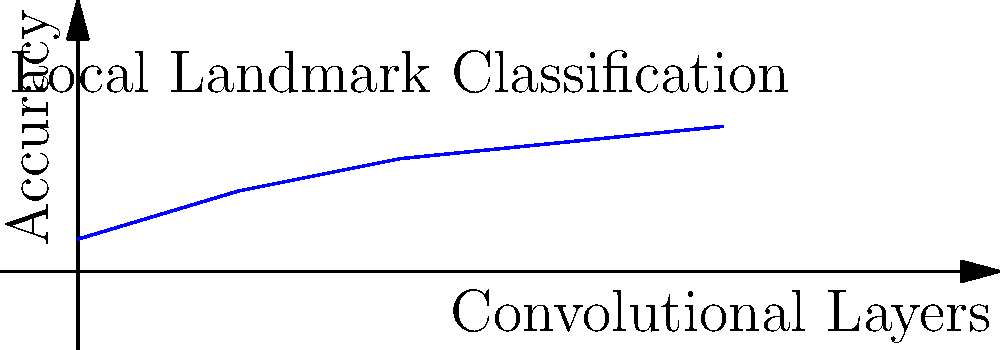Given the graph showing the relationship between the number of convolutional layers and the accuracy of a CNN model for classifying local landmarks, what is the optimal number of convolutional layers to achieve the best balance between accuracy and model complexity? To determine the optimal number of convolutional layers, we need to analyze the graph:

1. The x-axis represents the number of convolutional layers, ranging from 0 to 4.
2. The y-axis represents the accuracy of the model, ranging from 0 to 1 (or 0% to 100%).
3. The blue line shows how accuracy increases with more convolutional layers.

Let's examine the trend:
- With 0 layers, accuracy is very low (0.2 or 20%).
- Adding 1 layer significantly improves accuracy to 0.5 (50%).
- The second layer further improves accuracy to 0.7 (70%).
- The third layer shows a smaller improvement to 0.8 (80%).
- The fourth layer only marginally improves accuracy to 0.9 (90%).

The optimal number of layers balances accuracy gains with model complexity. After 3 layers, the accuracy improvement diminishes, indicating diminishing returns. Adding more layers beyond this point increases model complexity without substantial accuracy gains.

Therefore, the optimal number of convolutional layers is 3, as it provides high accuracy (80%) while avoiding unnecessary complexity.
Answer: 3 layers 